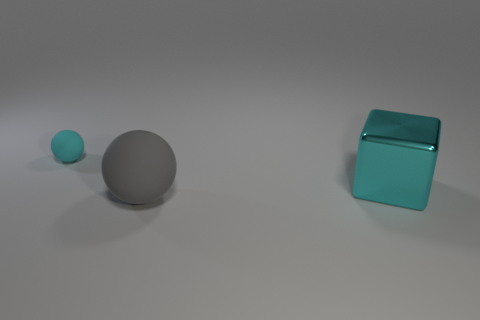What might be the purpose of these objects? These objects could serve educational purposes, such as teaching about geometry, color, and size relationships, or they could be part of a minimalist art installation emphasizing form and color. 